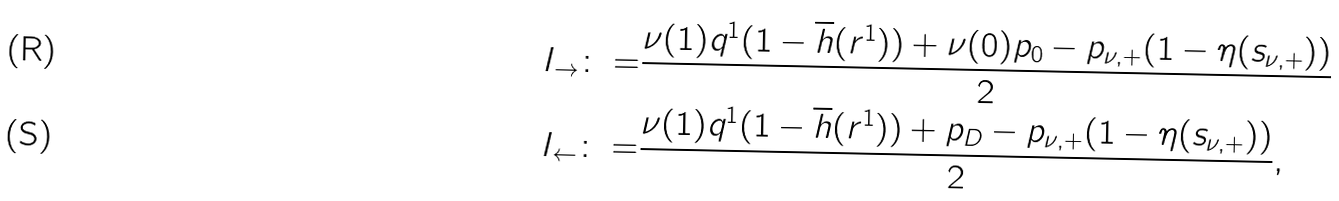<formula> <loc_0><loc_0><loc_500><loc_500>I _ { \to } \colon = & \frac { \nu ( 1 ) q ^ { 1 } ( 1 - \overline { h } ( r ^ { 1 } ) ) + \nu ( 0 ) p _ { 0 } - p _ { \nu , + } ( 1 - \eta ( s _ { \nu , + } ) ) } { 2 } \\ I _ { \leftarrow } \colon = & \frac { \nu ( 1 ) q ^ { 1 } ( 1 - \overline { h } ( r ^ { 1 } ) ) + p _ { D } - p _ { \nu , + } ( 1 - \eta ( s _ { \nu , + } ) ) } { 2 } ,</formula> 